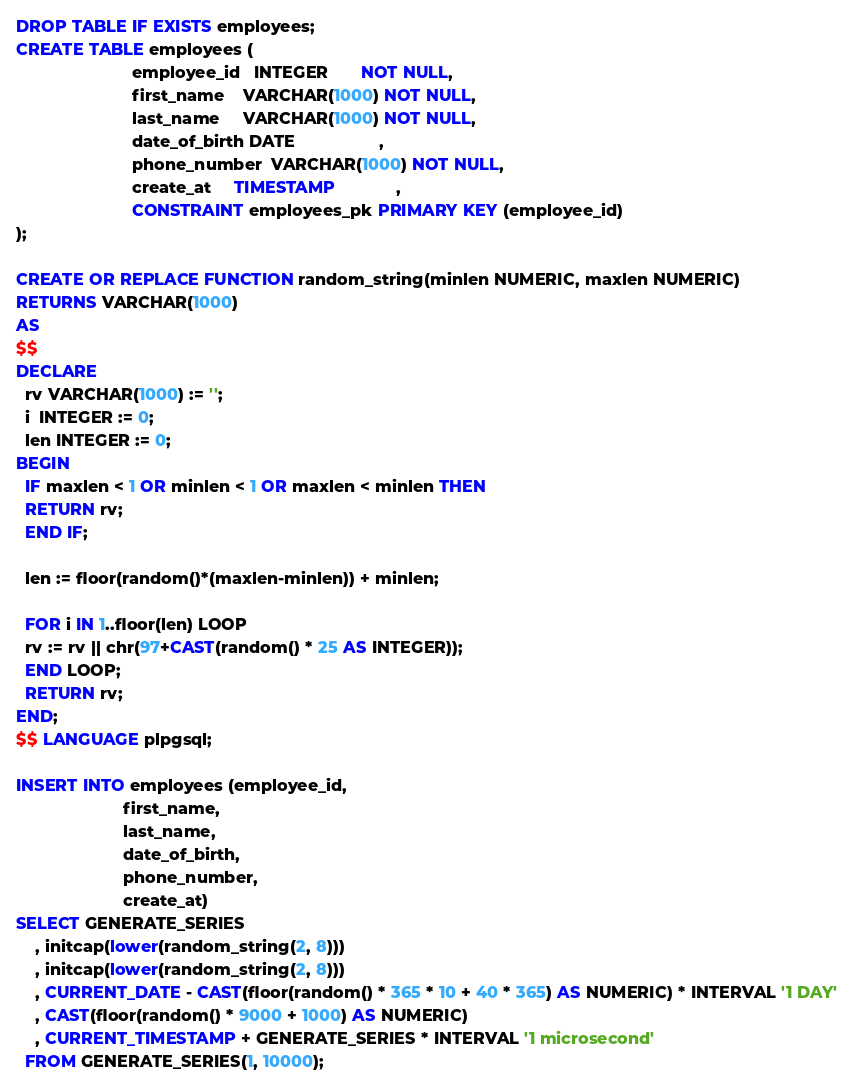<code> <loc_0><loc_0><loc_500><loc_500><_SQL_>DROP TABLE IF EXISTS employees;
CREATE TABLE employees (
                         employee_id   INTEGER       NOT NULL,
                         first_name    VARCHAR(1000) NOT NULL,
                         last_name     VARCHAR(1000) NOT NULL,
                         date_of_birth DATE                  ,
                         phone_number  VARCHAR(1000) NOT NULL,
                         create_at     TIMESTAMP             ,
                         CONSTRAINT employees_pk PRIMARY KEY (employee_id)
);

CREATE OR REPLACE FUNCTION random_string(minlen NUMERIC, maxlen NUMERIC)
RETURNS VARCHAR(1000)
AS
$$
DECLARE
  rv VARCHAR(1000) := '';
  i  INTEGER := 0;
  len INTEGER := 0;
BEGIN
  IF maxlen < 1 OR minlen < 1 OR maxlen < minlen THEN
  RETURN rv;
  END IF;

  len := floor(random()*(maxlen-minlen)) + minlen;

  FOR i IN 1..floor(len) LOOP
  rv := rv || chr(97+CAST(random() * 25 AS INTEGER));
  END LOOP;
  RETURN rv;
END;
$$ LANGUAGE plpgsql;

INSERT INTO employees (employee_id,
                       first_name,
                       last_name,
                       date_of_birth,
                       phone_number,
                       create_at)
SELECT GENERATE_SERIES
    , initcap(lower(random_string(2, 8)))
    , initcap(lower(random_string(2, 8)))
    , CURRENT_DATE - CAST(floor(random() * 365 * 10 + 40 * 365) AS NUMERIC) * INTERVAL '1 DAY'
    , CAST(floor(random() * 9000 + 1000) AS NUMERIC)
    , CURRENT_TIMESTAMP + GENERATE_SERIES * INTERVAL '1 microsecond'
  FROM GENERATE_SERIES(1, 10000);</code> 